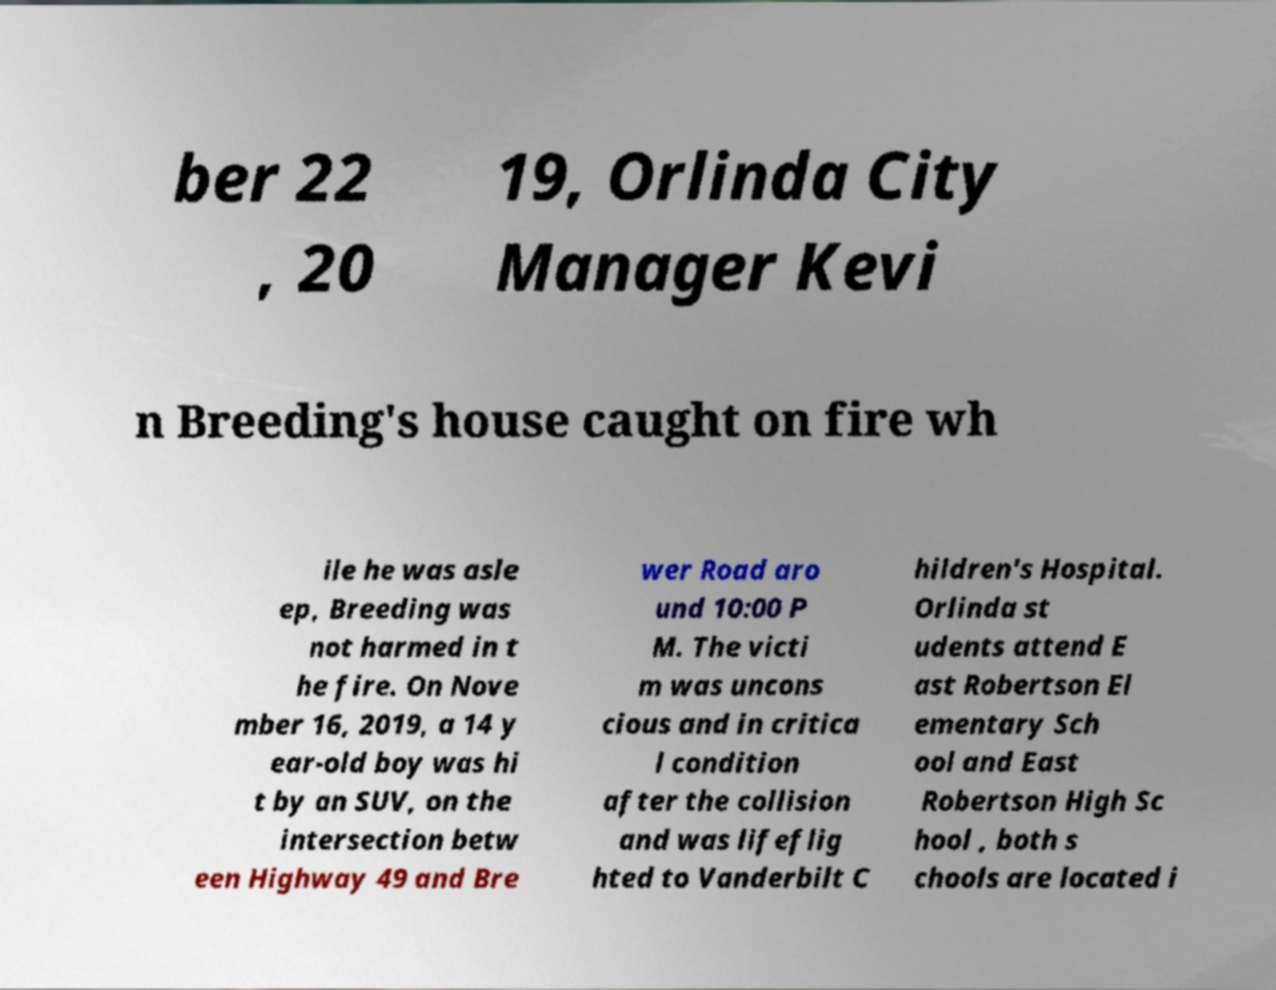For documentation purposes, I need the text within this image transcribed. Could you provide that? ber 22 , 20 19, Orlinda City Manager Kevi n Breeding's house caught on fire wh ile he was asle ep, Breeding was not harmed in t he fire. On Nove mber 16, 2019, a 14 y ear-old boy was hi t by an SUV, on the intersection betw een Highway 49 and Bre wer Road aro und 10:00 P M. The victi m was uncons cious and in critica l condition after the collision and was lifeflig hted to Vanderbilt C hildren's Hospital. Orlinda st udents attend E ast Robertson El ementary Sch ool and East Robertson High Sc hool , both s chools are located i 